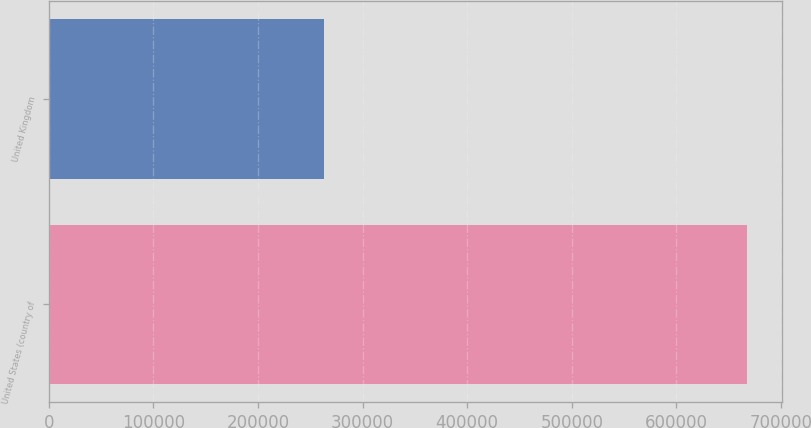Convert chart. <chart><loc_0><loc_0><loc_500><loc_500><bar_chart><fcel>United States (country of<fcel>United Kingdom<nl><fcel>667878<fcel>262613<nl></chart> 